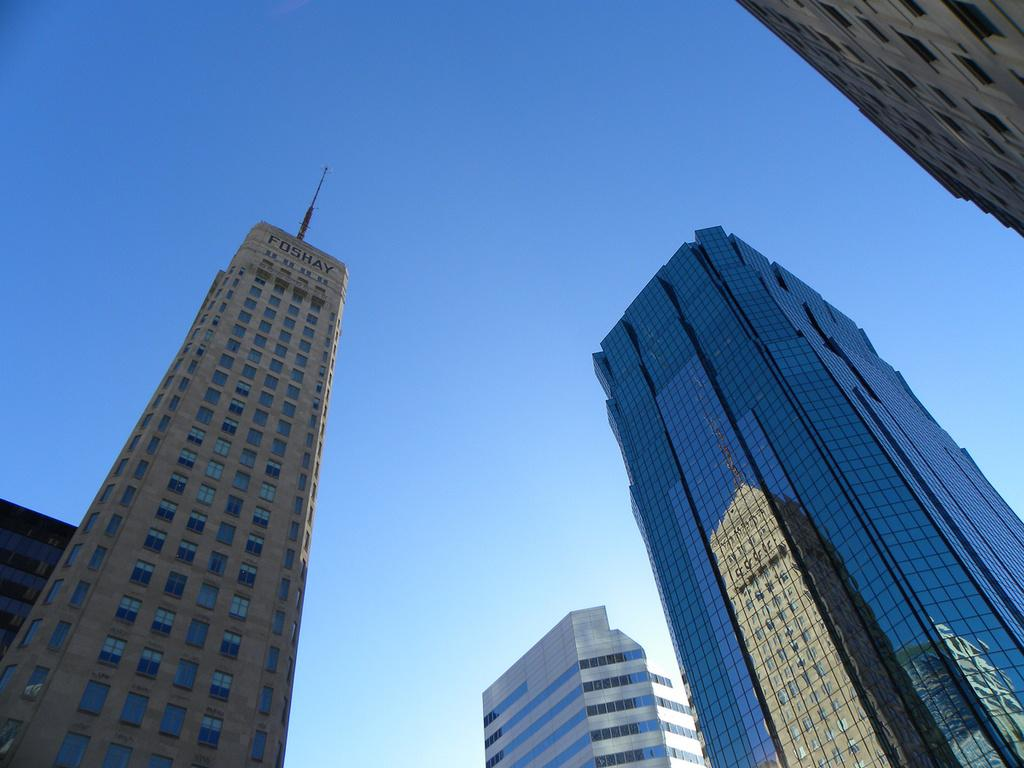What type of structures can be seen in the image? There are buildings in the image. What part of the natural environment is visible in the image? The sky is visible in the background of the image. What type of cheese is being ordered by the buildings in the image? There is no cheese or order present in the image; it only features buildings and the sky. 